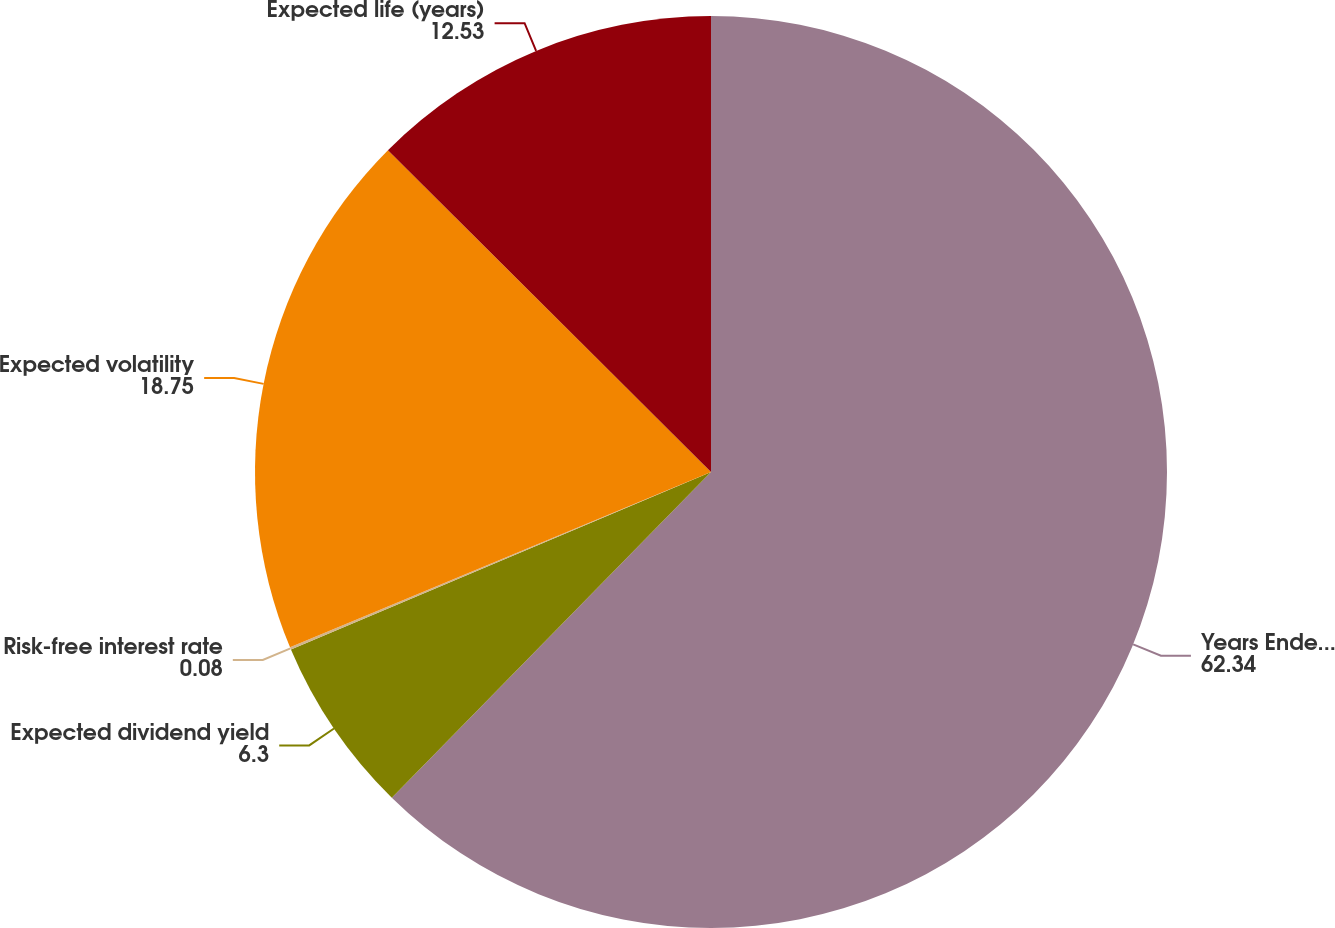<chart> <loc_0><loc_0><loc_500><loc_500><pie_chart><fcel>Years Ended December 31<fcel>Expected dividend yield<fcel>Risk-free interest rate<fcel>Expected volatility<fcel>Expected life (years)<nl><fcel>62.34%<fcel>6.3%<fcel>0.08%<fcel>18.75%<fcel>12.53%<nl></chart> 